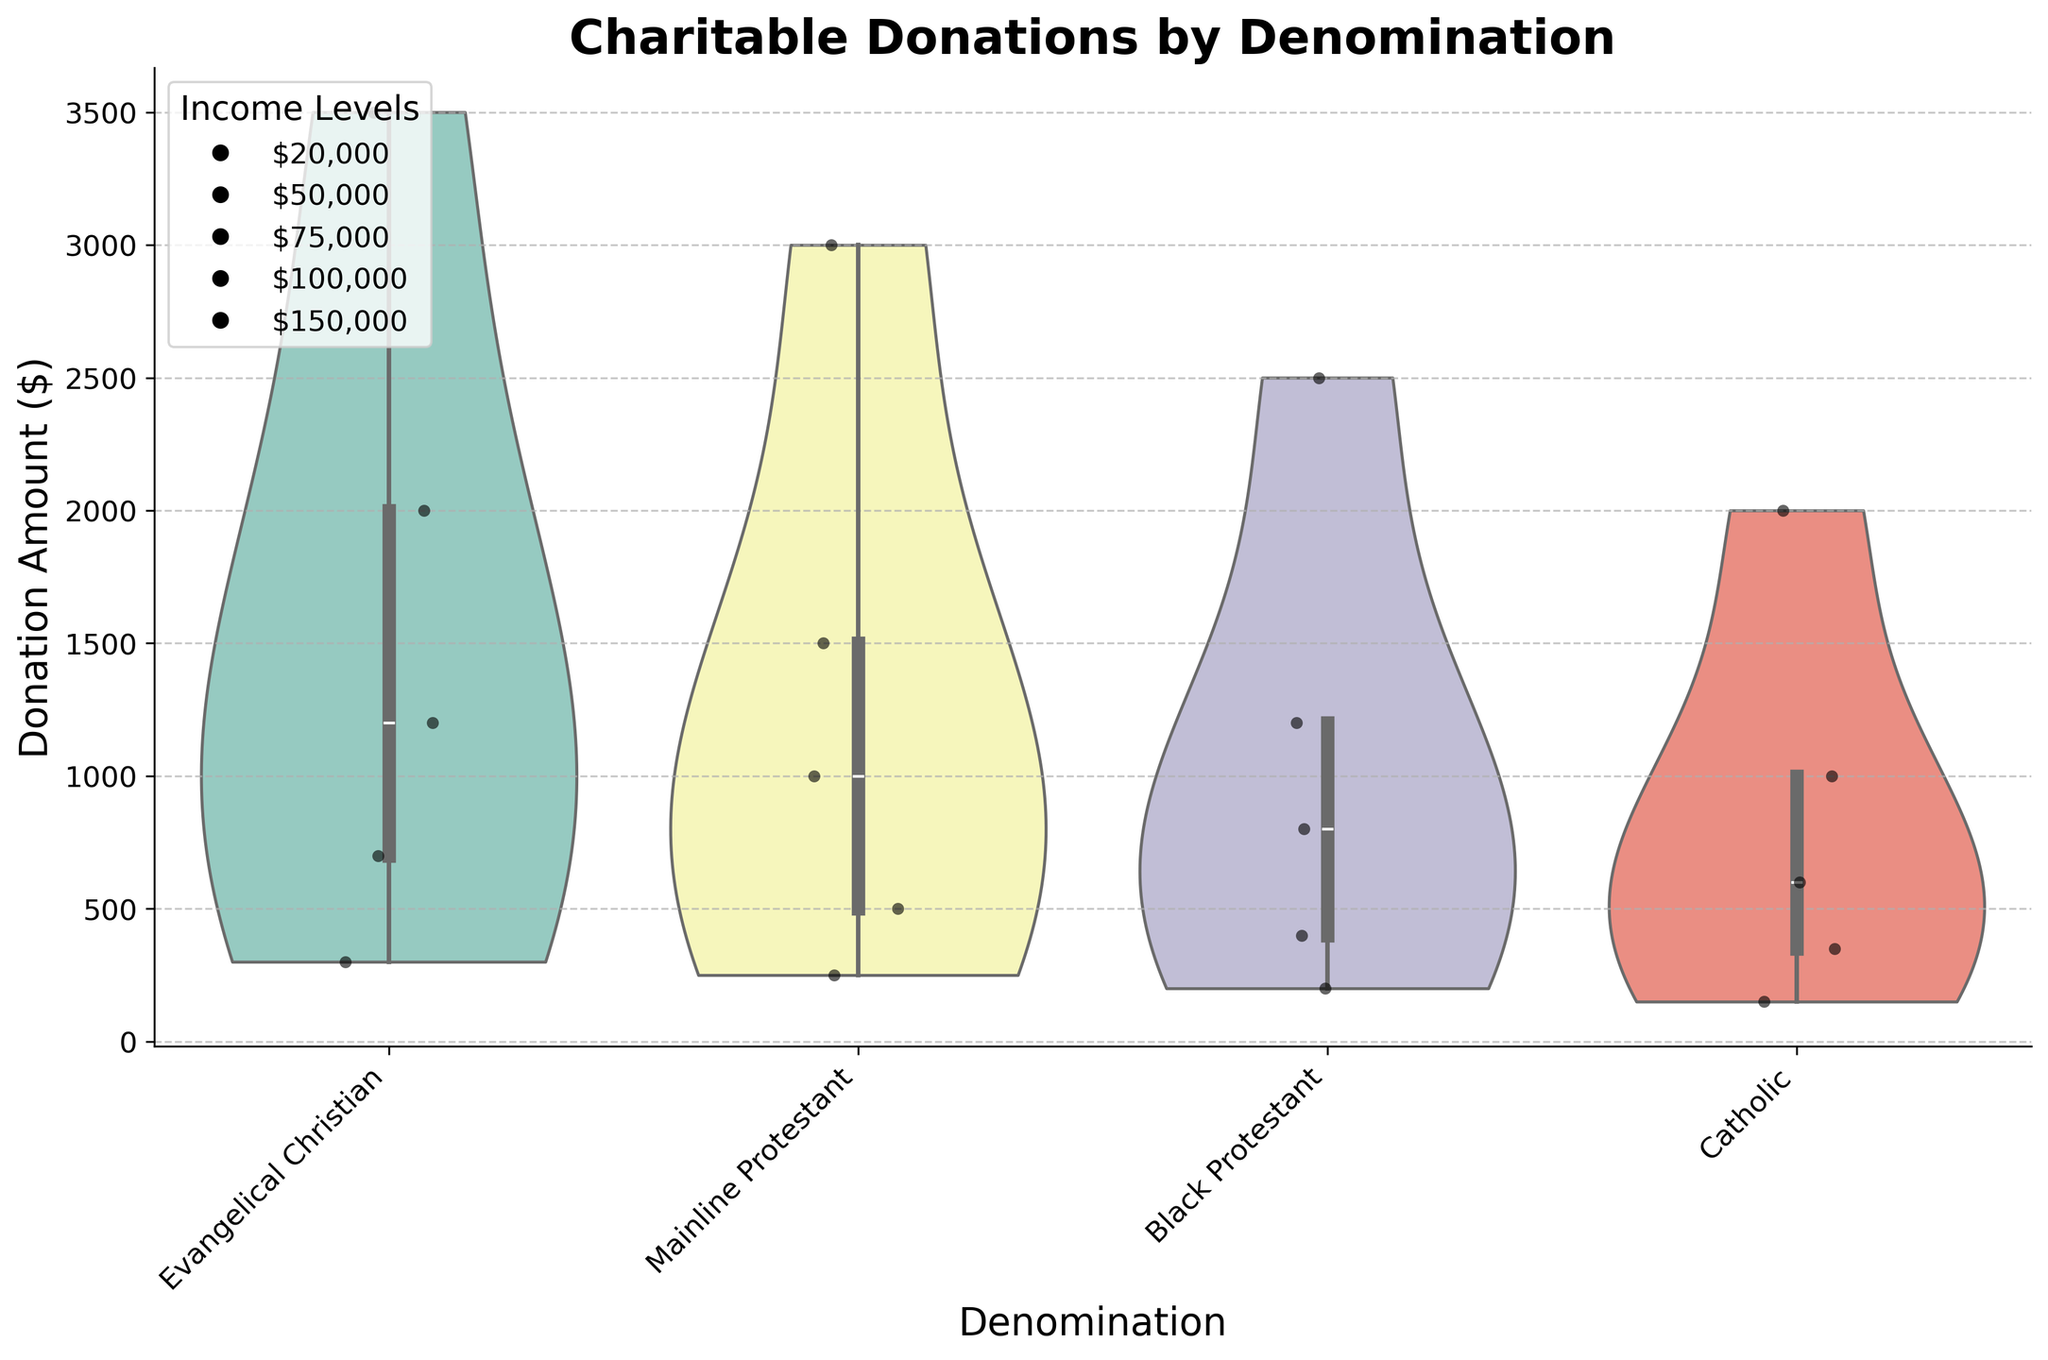What's the title of the figure? The title of the figure is found at the top and usually describes the main topic or objective of the visualization.
Answer: Charitable Donations by Denomination What is the highest donation amount observed for the Evangelical Christian group? Look at the violin plot and jittered points for the Evangelical Christian group; identify the point that reaches the highest value on the y-axis.
Answer: 3500 Which denomination shows the smallest range of donation amounts? Observing the spread of each violin, the smallest range indicates less variability in donations. The Catholic group's violin plot is the narrowest.
Answer: Catholic Between Mainline Protestant and Black Protestant, which group has a higher median donation amount? The median is often represented by a line in the violin plot. Compare the positions of these lines in both denominations.
Answer: Mainline Protestant How do donation amounts increase with income levels for the Evangelical Christian group? Identify the points representing different income levels within the Evangelical Christian group and observe the corresponding donation amounts. Higher income levels should show higher donation amounts.
Answer: Donation amounts increase as income levels increase Which group has the most outlier donations? Outliers are represented by points that fall outside the main violin shape. Compare the number of points sticking out for each group.
Answer: Evangelical Christian What is the median donation amount for the Catholic group? Identify the line within the violin plot for the Catholic group which represents the median donation amount.
Answer: 600 Compare the spread of donation amounts within the Black Protestant and Catholic groups. Which has a wider spread? The spread can be observed by looking at the width of the violin plots. A wider violin plot indicates a larger spread. Black Protestant has a wider range.
Answer: Black Protestant has a wider spread Which denomination shows a noticeable increase in donation amounts at the $100,000 income level? Identify the changes in donation amounts for each denomination around the $100,000 income level. Evangelical Christian shows a noticeable increase.
Answer: Evangelical Christian What general trend do you observe across all denominations as income level increases? General trends can be observed by looking at the positioning of jittered points and shapes of violin plots across income levels. Donation amounts tend to increase with rising income levels across all denominations.
Answer: Donation amounts increase with income 